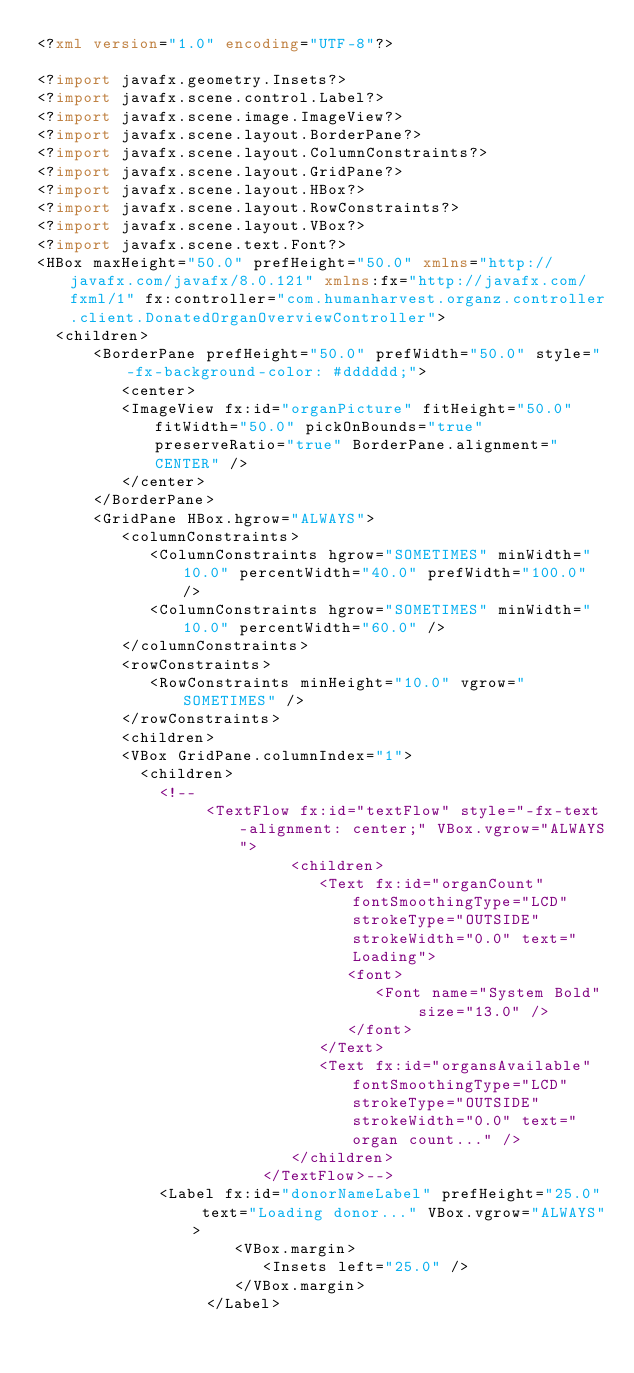<code> <loc_0><loc_0><loc_500><loc_500><_XML_><?xml version="1.0" encoding="UTF-8"?>

<?import javafx.geometry.Insets?>
<?import javafx.scene.control.Label?>
<?import javafx.scene.image.ImageView?>
<?import javafx.scene.layout.BorderPane?>
<?import javafx.scene.layout.ColumnConstraints?>
<?import javafx.scene.layout.GridPane?>
<?import javafx.scene.layout.HBox?>
<?import javafx.scene.layout.RowConstraints?>
<?import javafx.scene.layout.VBox?>
<?import javafx.scene.text.Font?>
<HBox maxHeight="50.0" prefHeight="50.0" xmlns="http://javafx.com/javafx/8.0.121" xmlns:fx="http://javafx.com/fxml/1" fx:controller="com.humanharvest.organz.controller.client.DonatedOrganOverviewController">
  <children>
      <BorderPane prefHeight="50.0" prefWidth="50.0" style="-fx-background-color: #dddddd;">
         <center>
         <ImageView fx:id="organPicture" fitHeight="50.0" fitWidth="50.0" pickOnBounds="true" preserveRatio="true" BorderPane.alignment="CENTER" />
         </center>
      </BorderPane>
      <GridPane HBox.hgrow="ALWAYS">
         <columnConstraints>
            <ColumnConstraints hgrow="SOMETIMES" minWidth="10.0" percentWidth="40.0" prefWidth="100.0" />
            <ColumnConstraints hgrow="SOMETIMES" minWidth="10.0" percentWidth="60.0" />
         </columnConstraints>
         <rowConstraints>
            <RowConstraints minHeight="10.0" vgrow="SOMETIMES" />
         </rowConstraints>
         <children>
         <VBox GridPane.columnIndex="1">
           <children>
             <!--
                  <TextFlow fx:id="textFlow" style="-fx-text-alignment: center;" VBox.vgrow="ALWAYS">
                           <children>
                              <Text fx:id="organCount" fontSmoothingType="LCD" strokeType="OUTSIDE" strokeWidth="0.0" text="Loading">
                                 <font>
                                    <Font name="System Bold" size="13.0" />
                                 </font>
                              </Text>
                              <Text fx:id="organsAvailable" fontSmoothingType="LCD" strokeType="OUTSIDE" strokeWidth="0.0" text=" organ count..." />
                           </children>
                        </TextFlow>-->
             <Label fx:id="donorNameLabel" prefHeight="25.0" text="Loading donor..." VBox.vgrow="ALWAYS">
                     <VBox.margin>
                        <Insets left="25.0" />
                     </VBox.margin>
                  </Label></code> 